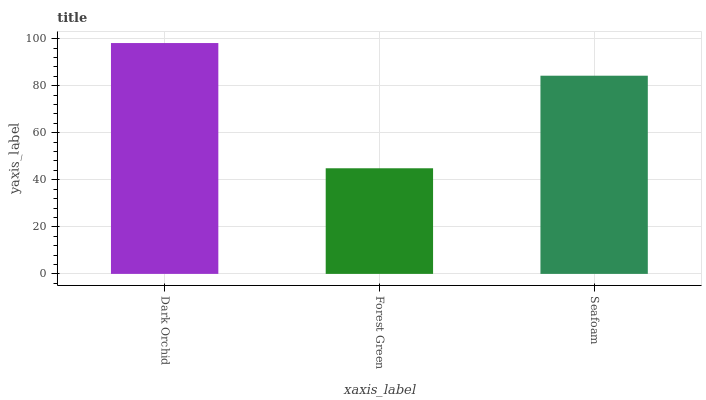Is Forest Green the minimum?
Answer yes or no. Yes. Is Dark Orchid the maximum?
Answer yes or no. Yes. Is Seafoam the minimum?
Answer yes or no. No. Is Seafoam the maximum?
Answer yes or no. No. Is Seafoam greater than Forest Green?
Answer yes or no. Yes. Is Forest Green less than Seafoam?
Answer yes or no. Yes. Is Forest Green greater than Seafoam?
Answer yes or no. No. Is Seafoam less than Forest Green?
Answer yes or no. No. Is Seafoam the high median?
Answer yes or no. Yes. Is Seafoam the low median?
Answer yes or no. Yes. Is Dark Orchid the high median?
Answer yes or no. No. Is Dark Orchid the low median?
Answer yes or no. No. 